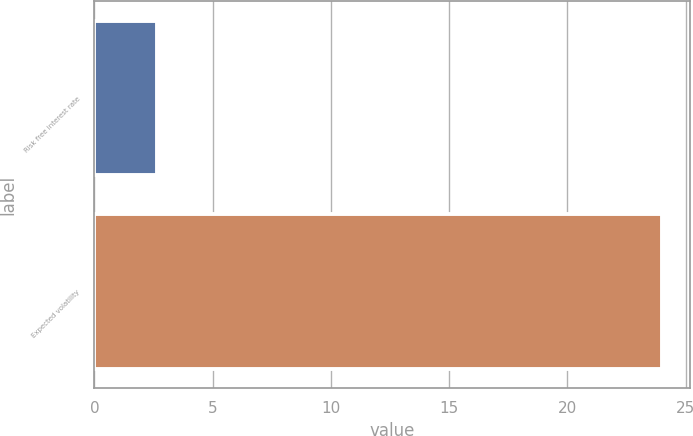Convert chart. <chart><loc_0><loc_0><loc_500><loc_500><bar_chart><fcel>Risk free interest rate<fcel>Expected volatility<nl><fcel>2.63<fcel>24<nl></chart> 